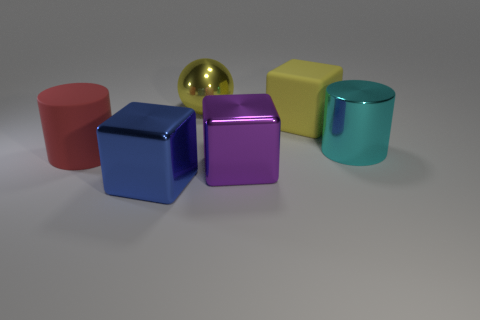Is the number of large blue shiny blocks greater than the number of green metallic balls?
Provide a short and direct response. Yes. What number of big cyan cylinders are in front of the matte thing behind the metal thing right of the large yellow cube?
Your answer should be compact. 1. The red rubber object has what shape?
Your response must be concise. Cylinder. How many other objects are the same material as the purple block?
Keep it short and to the point. 3. Do the purple cube and the blue metallic object have the same size?
Ensure brevity in your answer.  Yes. There is a big rubber object that is on the right side of the large shiny ball; what shape is it?
Give a very brief answer. Cube. There is a cube that is behind the big cylinder to the left of the large shiny cylinder; what is its color?
Offer a very short reply. Yellow. Do the big matte thing that is behind the cyan metallic cylinder and the large metallic object that is behind the big cyan metallic object have the same shape?
Offer a very short reply. No. There is a cyan metal thing that is the same size as the purple metal thing; what shape is it?
Your answer should be very brief. Cylinder. There is a large block that is the same material as the large red thing; what is its color?
Offer a very short reply. Yellow. 